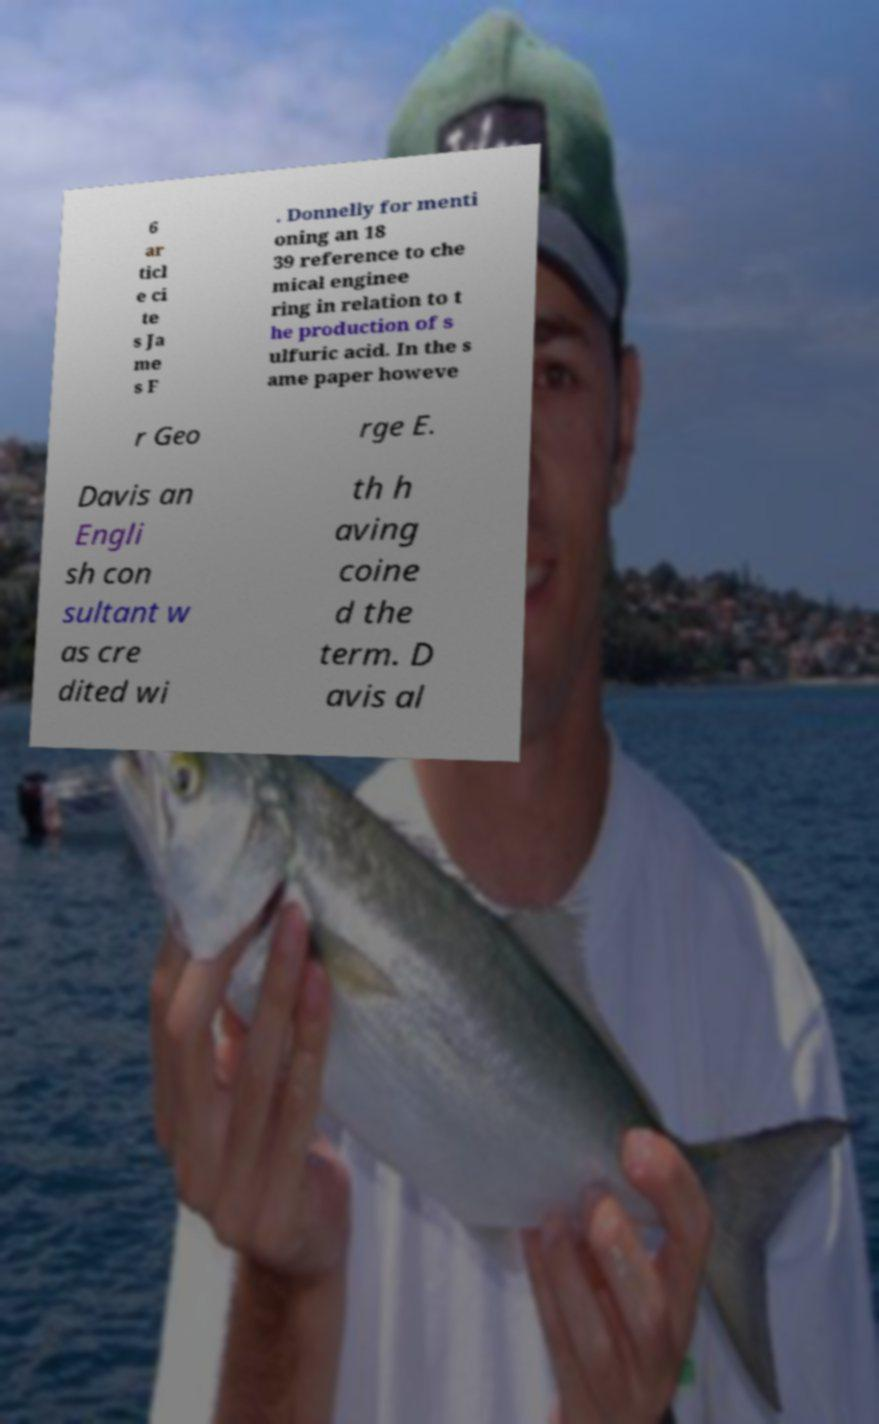What messages or text are displayed in this image? I need them in a readable, typed format. 6 ar ticl e ci te s Ja me s F . Donnelly for menti oning an 18 39 reference to che mical enginee ring in relation to t he production of s ulfuric acid. In the s ame paper howeve r Geo rge E. Davis an Engli sh con sultant w as cre dited wi th h aving coine d the term. D avis al 